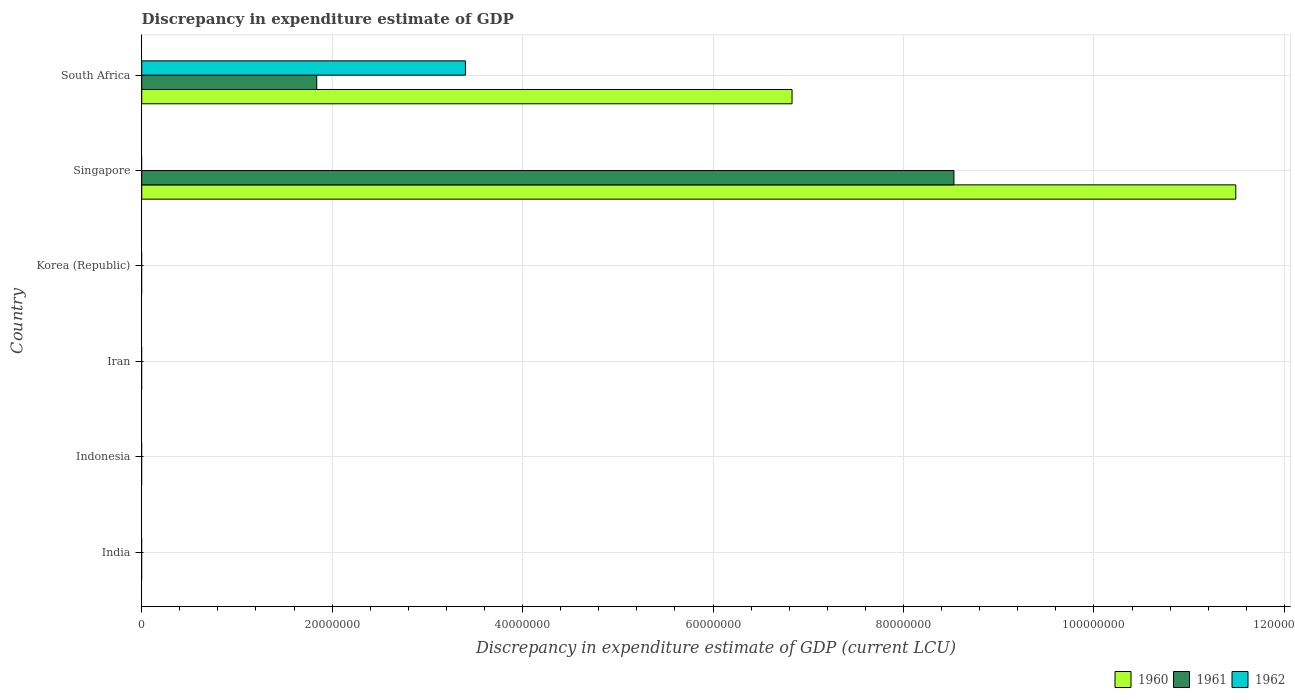How many different coloured bars are there?
Your answer should be compact. 3. Are the number of bars per tick equal to the number of legend labels?
Keep it short and to the point. No. Are the number of bars on each tick of the Y-axis equal?
Your answer should be compact. No. What is the discrepancy in expenditure estimate of GDP in 1962 in Iran?
Provide a short and direct response. 0. Across all countries, what is the maximum discrepancy in expenditure estimate of GDP in 1962?
Your response must be concise. 3.40e+07. Across all countries, what is the minimum discrepancy in expenditure estimate of GDP in 1961?
Your answer should be very brief. 0. In which country was the discrepancy in expenditure estimate of GDP in 1960 maximum?
Keep it short and to the point. Singapore. What is the total discrepancy in expenditure estimate of GDP in 1960 in the graph?
Provide a succinct answer. 1.83e+08. What is the difference between the discrepancy in expenditure estimate of GDP in 1960 in Singapore and that in South Africa?
Ensure brevity in your answer.  4.66e+07. What is the difference between the discrepancy in expenditure estimate of GDP in 1961 in Korea (Republic) and the discrepancy in expenditure estimate of GDP in 1960 in Indonesia?
Make the answer very short. 0. What is the average discrepancy in expenditure estimate of GDP in 1960 per country?
Keep it short and to the point. 3.05e+07. What is the difference between the discrepancy in expenditure estimate of GDP in 1961 and discrepancy in expenditure estimate of GDP in 1960 in Singapore?
Provide a short and direct response. -2.96e+07. In how many countries, is the discrepancy in expenditure estimate of GDP in 1960 greater than 80000000 LCU?
Offer a terse response. 1. What is the difference between the highest and the lowest discrepancy in expenditure estimate of GDP in 1960?
Your answer should be very brief. 1.15e+08. In how many countries, is the discrepancy in expenditure estimate of GDP in 1962 greater than the average discrepancy in expenditure estimate of GDP in 1962 taken over all countries?
Your answer should be compact. 1. Are all the bars in the graph horizontal?
Ensure brevity in your answer.  Yes. What is the title of the graph?
Your answer should be compact. Discrepancy in expenditure estimate of GDP. What is the label or title of the X-axis?
Give a very brief answer. Discrepancy in expenditure estimate of GDP (current LCU). What is the label or title of the Y-axis?
Provide a succinct answer. Country. What is the Discrepancy in expenditure estimate of GDP (current LCU) in 1960 in India?
Your answer should be very brief. 0. What is the Discrepancy in expenditure estimate of GDP (current LCU) in 1961 in Indonesia?
Keep it short and to the point. 0. What is the Discrepancy in expenditure estimate of GDP (current LCU) in 1960 in Iran?
Your answer should be very brief. 0. What is the Discrepancy in expenditure estimate of GDP (current LCU) in 1961 in Iran?
Offer a very short reply. 0. What is the Discrepancy in expenditure estimate of GDP (current LCU) of 1962 in Iran?
Make the answer very short. 0. What is the Discrepancy in expenditure estimate of GDP (current LCU) of 1960 in Korea (Republic)?
Make the answer very short. 0. What is the Discrepancy in expenditure estimate of GDP (current LCU) of 1961 in Korea (Republic)?
Your answer should be compact. 0. What is the Discrepancy in expenditure estimate of GDP (current LCU) of 1960 in Singapore?
Keep it short and to the point. 1.15e+08. What is the Discrepancy in expenditure estimate of GDP (current LCU) of 1961 in Singapore?
Make the answer very short. 8.53e+07. What is the Discrepancy in expenditure estimate of GDP (current LCU) of 1962 in Singapore?
Your answer should be very brief. 0. What is the Discrepancy in expenditure estimate of GDP (current LCU) of 1960 in South Africa?
Offer a very short reply. 6.83e+07. What is the Discrepancy in expenditure estimate of GDP (current LCU) in 1961 in South Africa?
Your response must be concise. 1.84e+07. What is the Discrepancy in expenditure estimate of GDP (current LCU) of 1962 in South Africa?
Ensure brevity in your answer.  3.40e+07. Across all countries, what is the maximum Discrepancy in expenditure estimate of GDP (current LCU) in 1960?
Your answer should be compact. 1.15e+08. Across all countries, what is the maximum Discrepancy in expenditure estimate of GDP (current LCU) of 1961?
Provide a short and direct response. 8.53e+07. Across all countries, what is the maximum Discrepancy in expenditure estimate of GDP (current LCU) of 1962?
Provide a succinct answer. 3.40e+07. Across all countries, what is the minimum Discrepancy in expenditure estimate of GDP (current LCU) of 1961?
Give a very brief answer. 0. Across all countries, what is the minimum Discrepancy in expenditure estimate of GDP (current LCU) of 1962?
Your response must be concise. 0. What is the total Discrepancy in expenditure estimate of GDP (current LCU) of 1960 in the graph?
Provide a succinct answer. 1.83e+08. What is the total Discrepancy in expenditure estimate of GDP (current LCU) in 1961 in the graph?
Your response must be concise. 1.04e+08. What is the total Discrepancy in expenditure estimate of GDP (current LCU) of 1962 in the graph?
Offer a very short reply. 3.40e+07. What is the difference between the Discrepancy in expenditure estimate of GDP (current LCU) in 1960 in Singapore and that in South Africa?
Ensure brevity in your answer.  4.66e+07. What is the difference between the Discrepancy in expenditure estimate of GDP (current LCU) in 1961 in Singapore and that in South Africa?
Your answer should be very brief. 6.69e+07. What is the difference between the Discrepancy in expenditure estimate of GDP (current LCU) of 1960 in Singapore and the Discrepancy in expenditure estimate of GDP (current LCU) of 1961 in South Africa?
Give a very brief answer. 9.65e+07. What is the difference between the Discrepancy in expenditure estimate of GDP (current LCU) of 1960 in Singapore and the Discrepancy in expenditure estimate of GDP (current LCU) of 1962 in South Africa?
Give a very brief answer. 8.09e+07. What is the difference between the Discrepancy in expenditure estimate of GDP (current LCU) of 1961 in Singapore and the Discrepancy in expenditure estimate of GDP (current LCU) of 1962 in South Africa?
Keep it short and to the point. 5.13e+07. What is the average Discrepancy in expenditure estimate of GDP (current LCU) of 1960 per country?
Make the answer very short. 3.05e+07. What is the average Discrepancy in expenditure estimate of GDP (current LCU) in 1961 per country?
Provide a succinct answer. 1.73e+07. What is the average Discrepancy in expenditure estimate of GDP (current LCU) of 1962 per country?
Ensure brevity in your answer.  5.67e+06. What is the difference between the Discrepancy in expenditure estimate of GDP (current LCU) of 1960 and Discrepancy in expenditure estimate of GDP (current LCU) of 1961 in Singapore?
Your answer should be compact. 2.96e+07. What is the difference between the Discrepancy in expenditure estimate of GDP (current LCU) in 1960 and Discrepancy in expenditure estimate of GDP (current LCU) in 1961 in South Africa?
Offer a terse response. 4.99e+07. What is the difference between the Discrepancy in expenditure estimate of GDP (current LCU) in 1960 and Discrepancy in expenditure estimate of GDP (current LCU) in 1962 in South Africa?
Your response must be concise. 3.43e+07. What is the difference between the Discrepancy in expenditure estimate of GDP (current LCU) of 1961 and Discrepancy in expenditure estimate of GDP (current LCU) of 1962 in South Africa?
Make the answer very short. -1.56e+07. What is the ratio of the Discrepancy in expenditure estimate of GDP (current LCU) of 1960 in Singapore to that in South Africa?
Provide a short and direct response. 1.68. What is the ratio of the Discrepancy in expenditure estimate of GDP (current LCU) of 1961 in Singapore to that in South Africa?
Your answer should be compact. 4.64. What is the difference between the highest and the lowest Discrepancy in expenditure estimate of GDP (current LCU) of 1960?
Make the answer very short. 1.15e+08. What is the difference between the highest and the lowest Discrepancy in expenditure estimate of GDP (current LCU) in 1961?
Make the answer very short. 8.53e+07. What is the difference between the highest and the lowest Discrepancy in expenditure estimate of GDP (current LCU) in 1962?
Make the answer very short. 3.40e+07. 